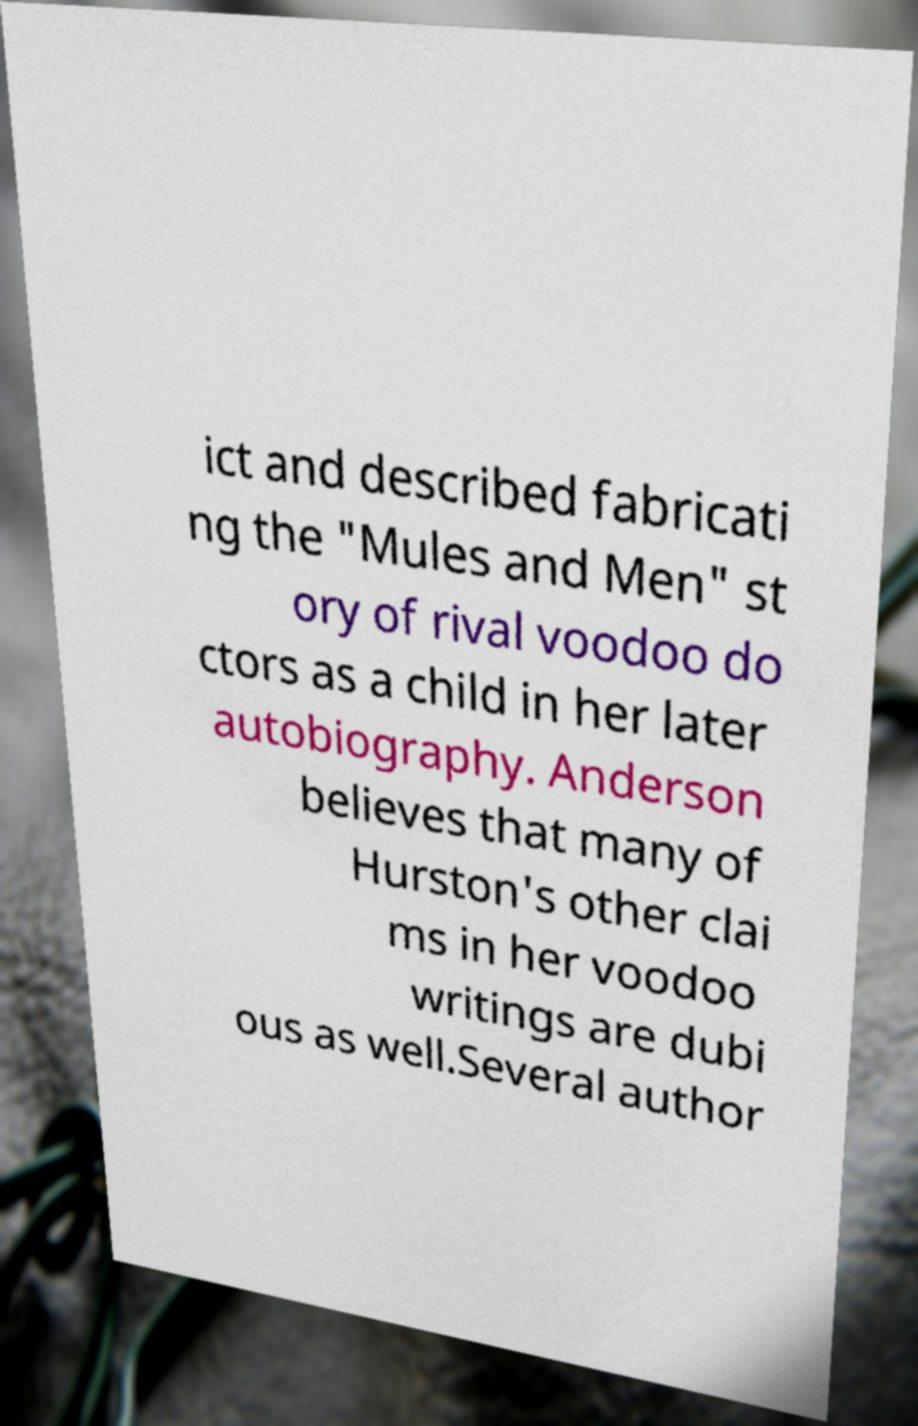Please read and relay the text visible in this image. What does it say? ict and described fabricati ng the "Mules and Men" st ory of rival voodoo do ctors as a child in her later autobiography. Anderson believes that many of Hurston's other clai ms in her voodoo writings are dubi ous as well.Several author 